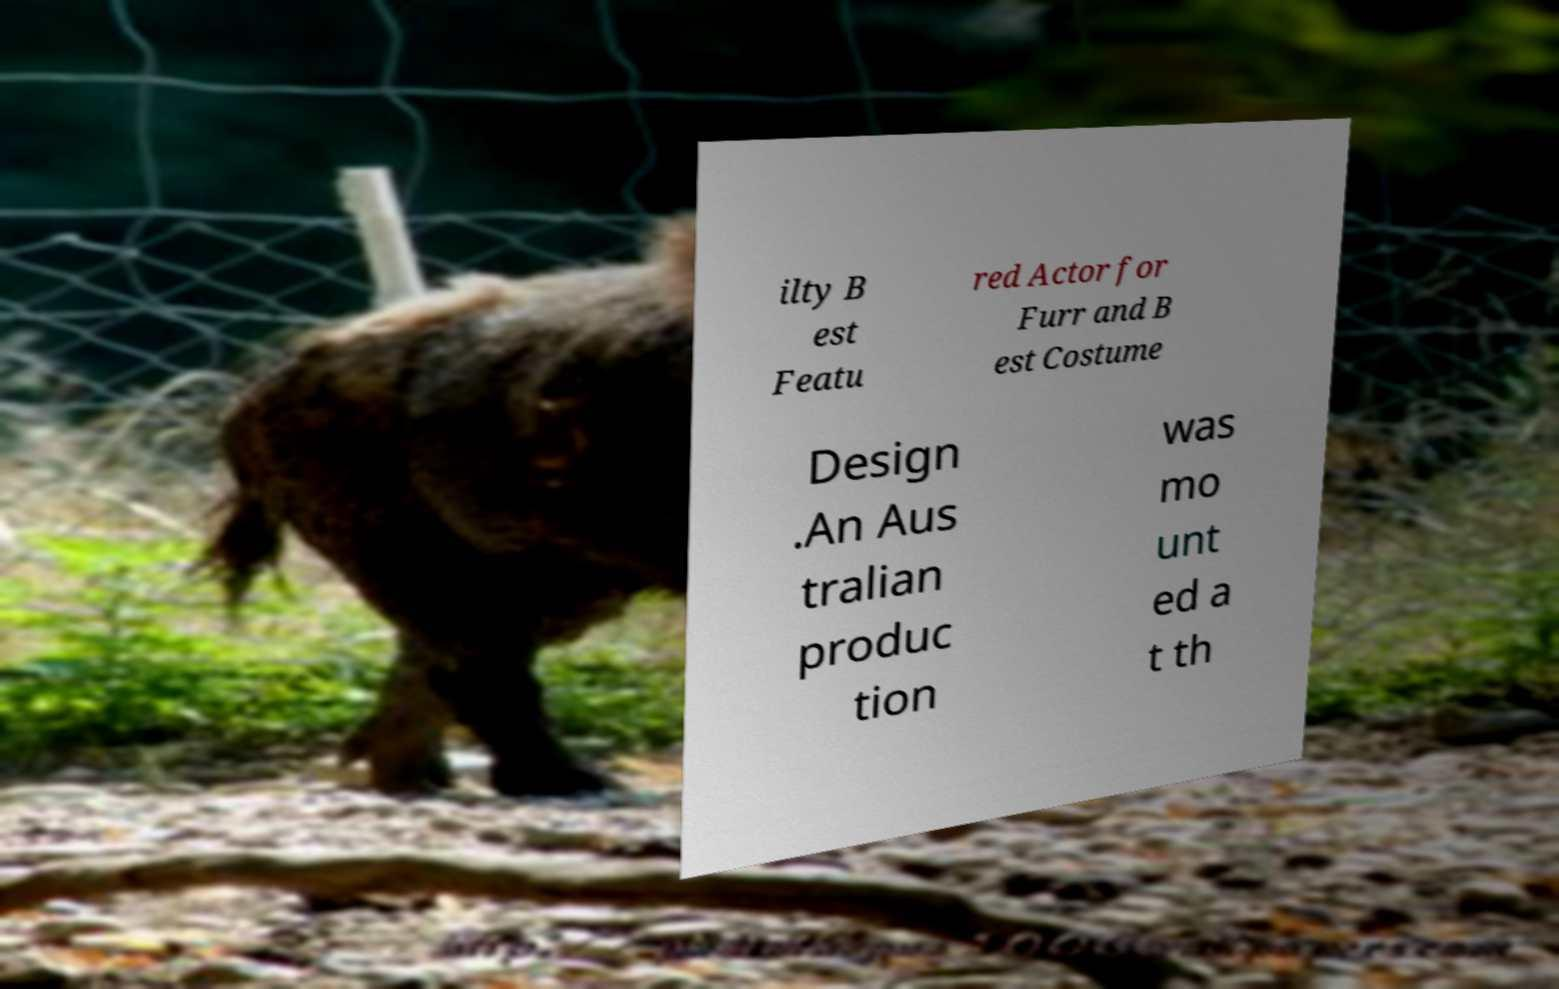Can you accurately transcribe the text from the provided image for me? ilty B est Featu red Actor for Furr and B est Costume Design .An Aus tralian produc tion was mo unt ed a t th 